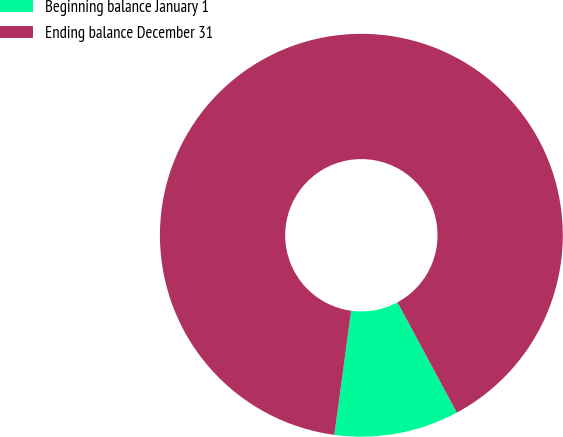Convert chart to OTSL. <chart><loc_0><loc_0><loc_500><loc_500><pie_chart><fcel>Beginning balance January 1<fcel>Ending balance December 31<nl><fcel>10.0%<fcel>90.0%<nl></chart> 